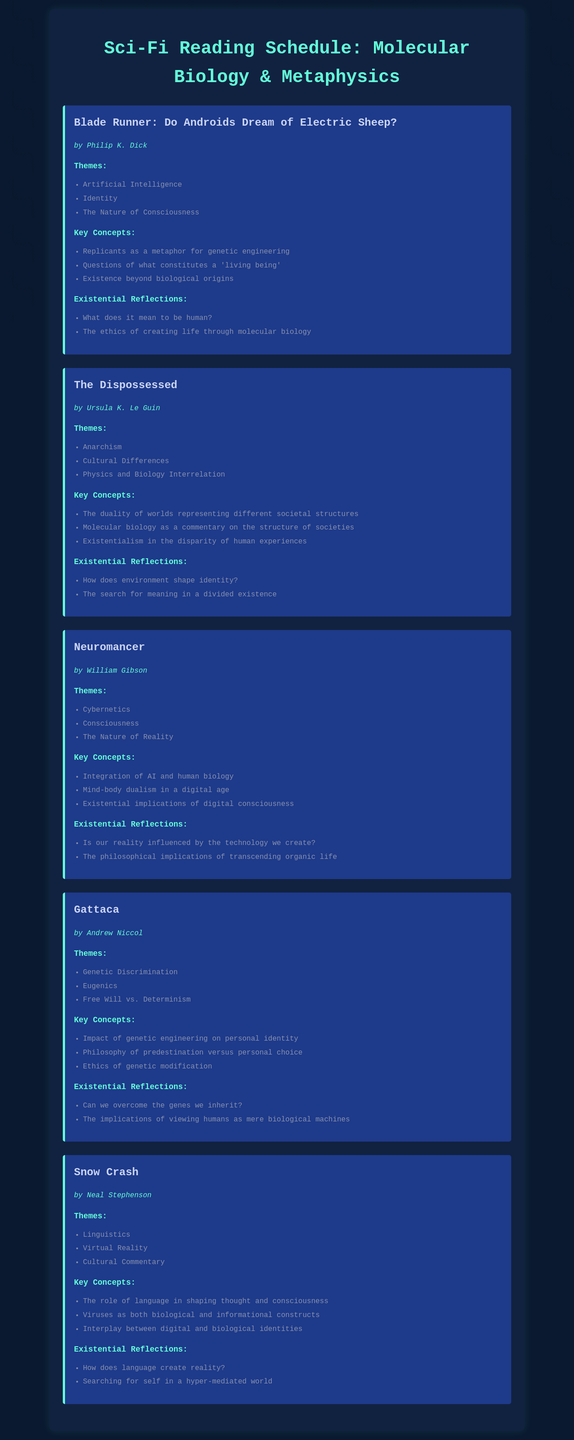What is the title of the first book? The title of the first book listed in the document is "Blade Runner: Do Androids Dream of Electric Sheep?".
Answer: Blade Runner: Do Androids Dream of Electric Sheep? Who is the author of "The Dispossessed"? The author of "The Dispossessed" is mentioned in the document as Ursula K. Le Guin.
Answer: Ursula K. Le Guin What theme is associated with "Gattaca"? The document lists genetic discrimination as a theme associated with "Gattaca".
Answer: Genetic Discrimination How many key concepts are listed for "Neuromancer"? The document provides three key concepts listed for "Neuromancer".
Answer: 3 What existential reflection is common to multiple books? One existential reflection noted is "What does it mean to be human?", which is relevant to multiple books.
Answer: What does it mean to be human? Which book explores the implications of digital consciousness? The document indicates that "Neuromancer" explores the implications of digital consciousness.
Answer: Neuromancer What type of commentary does "Snow Crash" provide? The document states that "Snow Crash" offers cultural commentary.
Answer: Cultural Commentary Which book discusses the ethics of genetic modification? "Gattaca" is noted in the document for discussing the ethics of genetic modification.
Answer: Gattaca What is the theme of cybernetics associated with? The theme of cybernetics is specifically associated with "Neuromancer".
Answer: Neuromancer 